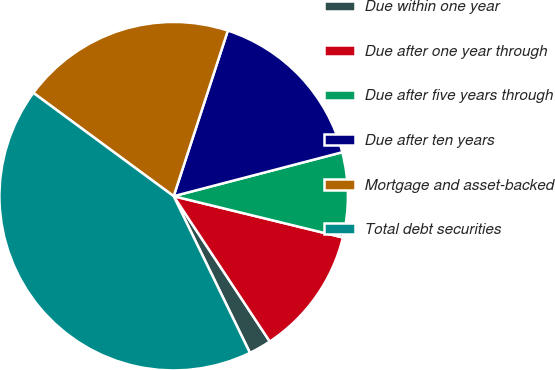Convert chart to OTSL. <chart><loc_0><loc_0><loc_500><loc_500><pie_chart><fcel>Due within one year<fcel>Due after one year through<fcel>Due after five years through<fcel>Due after ten years<fcel>Mortgage and asset-backed<fcel>Total debt securities<nl><fcel>2.09%<fcel>11.89%<fcel>7.87%<fcel>15.91%<fcel>19.93%<fcel>42.31%<nl></chart> 